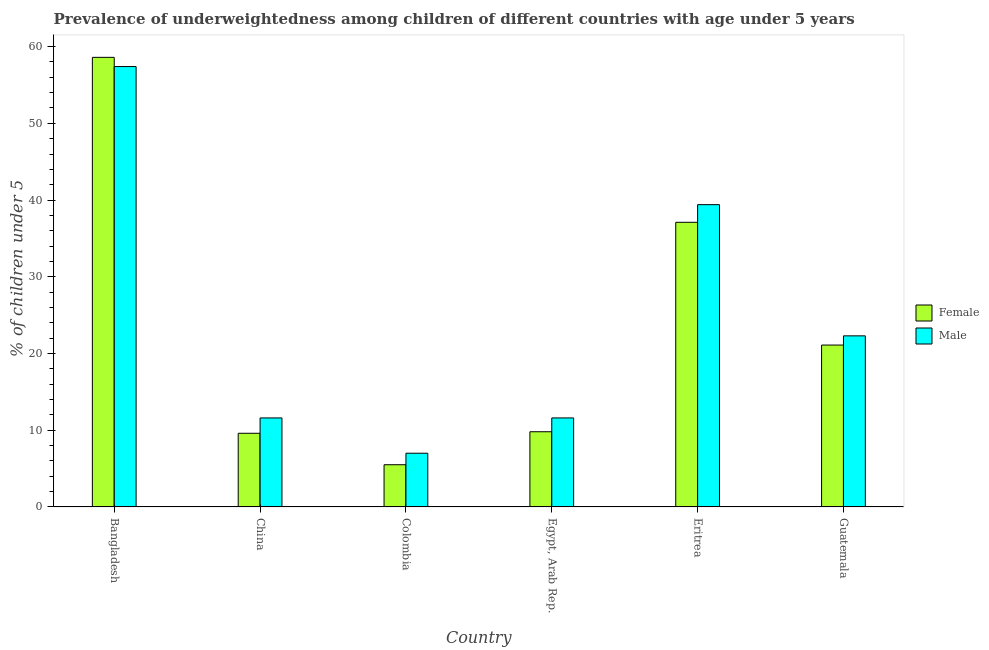How many different coloured bars are there?
Ensure brevity in your answer.  2. How many groups of bars are there?
Make the answer very short. 6. Are the number of bars on each tick of the X-axis equal?
Your response must be concise. Yes. How many bars are there on the 3rd tick from the left?
Ensure brevity in your answer.  2. How many bars are there on the 5th tick from the right?
Provide a short and direct response. 2. What is the label of the 5th group of bars from the left?
Provide a short and direct response. Eritrea. Across all countries, what is the maximum percentage of underweighted male children?
Make the answer very short. 57.4. In which country was the percentage of underweighted male children maximum?
Offer a terse response. Bangladesh. What is the total percentage of underweighted male children in the graph?
Provide a succinct answer. 149.3. What is the difference between the percentage of underweighted female children in China and that in Eritrea?
Offer a terse response. -27.5. What is the difference between the percentage of underweighted female children in China and the percentage of underweighted male children in Guatemala?
Offer a very short reply. -12.7. What is the average percentage of underweighted male children per country?
Offer a terse response. 24.88. What is the difference between the percentage of underweighted female children and percentage of underweighted male children in Guatemala?
Your response must be concise. -1.2. What is the ratio of the percentage of underweighted female children in Egypt, Arab Rep. to that in Guatemala?
Keep it short and to the point. 0.46. Is the difference between the percentage of underweighted male children in China and Eritrea greater than the difference between the percentage of underweighted female children in China and Eritrea?
Keep it short and to the point. No. What is the difference between the highest and the lowest percentage of underweighted male children?
Provide a short and direct response. 50.4. Is the sum of the percentage of underweighted male children in Bangladesh and Egypt, Arab Rep. greater than the maximum percentage of underweighted female children across all countries?
Provide a succinct answer. Yes. What does the 2nd bar from the right in Eritrea represents?
Give a very brief answer. Female. Are the values on the major ticks of Y-axis written in scientific E-notation?
Offer a very short reply. No. What is the title of the graph?
Offer a very short reply. Prevalence of underweightedness among children of different countries with age under 5 years. What is the label or title of the X-axis?
Give a very brief answer. Country. What is the label or title of the Y-axis?
Ensure brevity in your answer.   % of children under 5. What is the  % of children under 5 of Female in Bangladesh?
Provide a succinct answer. 58.6. What is the  % of children under 5 of Male in Bangladesh?
Ensure brevity in your answer.  57.4. What is the  % of children under 5 in Female in China?
Your response must be concise. 9.6. What is the  % of children under 5 of Male in China?
Provide a succinct answer. 11.6. What is the  % of children under 5 of Female in Egypt, Arab Rep.?
Provide a short and direct response. 9.8. What is the  % of children under 5 in Male in Egypt, Arab Rep.?
Your response must be concise. 11.6. What is the  % of children under 5 in Female in Eritrea?
Your response must be concise. 37.1. What is the  % of children under 5 of Male in Eritrea?
Your answer should be very brief. 39.4. What is the  % of children under 5 of Female in Guatemala?
Provide a succinct answer. 21.1. What is the  % of children under 5 of Male in Guatemala?
Your answer should be very brief. 22.3. Across all countries, what is the maximum  % of children under 5 in Female?
Provide a short and direct response. 58.6. Across all countries, what is the maximum  % of children under 5 of Male?
Offer a very short reply. 57.4. Across all countries, what is the minimum  % of children under 5 in Female?
Your response must be concise. 5.5. Across all countries, what is the minimum  % of children under 5 of Male?
Keep it short and to the point. 7. What is the total  % of children under 5 in Female in the graph?
Keep it short and to the point. 141.7. What is the total  % of children under 5 of Male in the graph?
Ensure brevity in your answer.  149.3. What is the difference between the  % of children under 5 of Male in Bangladesh and that in China?
Offer a terse response. 45.8. What is the difference between the  % of children under 5 in Female in Bangladesh and that in Colombia?
Provide a short and direct response. 53.1. What is the difference between the  % of children under 5 of Male in Bangladesh and that in Colombia?
Make the answer very short. 50.4. What is the difference between the  % of children under 5 of Female in Bangladesh and that in Egypt, Arab Rep.?
Keep it short and to the point. 48.8. What is the difference between the  % of children under 5 of Male in Bangladesh and that in Egypt, Arab Rep.?
Make the answer very short. 45.8. What is the difference between the  % of children under 5 of Male in Bangladesh and that in Eritrea?
Provide a short and direct response. 18. What is the difference between the  % of children under 5 in Female in Bangladesh and that in Guatemala?
Ensure brevity in your answer.  37.5. What is the difference between the  % of children under 5 in Male in Bangladesh and that in Guatemala?
Keep it short and to the point. 35.1. What is the difference between the  % of children under 5 in Female in China and that in Colombia?
Provide a succinct answer. 4.1. What is the difference between the  % of children under 5 in Female in China and that in Egypt, Arab Rep.?
Offer a terse response. -0.2. What is the difference between the  % of children under 5 of Male in China and that in Egypt, Arab Rep.?
Give a very brief answer. 0. What is the difference between the  % of children under 5 of Female in China and that in Eritrea?
Ensure brevity in your answer.  -27.5. What is the difference between the  % of children under 5 of Male in China and that in Eritrea?
Ensure brevity in your answer.  -27.8. What is the difference between the  % of children under 5 in Male in China and that in Guatemala?
Ensure brevity in your answer.  -10.7. What is the difference between the  % of children under 5 of Female in Colombia and that in Egypt, Arab Rep.?
Offer a very short reply. -4.3. What is the difference between the  % of children under 5 of Female in Colombia and that in Eritrea?
Make the answer very short. -31.6. What is the difference between the  % of children under 5 in Male in Colombia and that in Eritrea?
Ensure brevity in your answer.  -32.4. What is the difference between the  % of children under 5 of Female in Colombia and that in Guatemala?
Keep it short and to the point. -15.6. What is the difference between the  % of children under 5 of Male in Colombia and that in Guatemala?
Provide a short and direct response. -15.3. What is the difference between the  % of children under 5 of Female in Egypt, Arab Rep. and that in Eritrea?
Ensure brevity in your answer.  -27.3. What is the difference between the  % of children under 5 of Male in Egypt, Arab Rep. and that in Eritrea?
Your answer should be compact. -27.8. What is the difference between the  % of children under 5 in Female in Eritrea and that in Guatemala?
Your response must be concise. 16. What is the difference between the  % of children under 5 of Male in Eritrea and that in Guatemala?
Your answer should be compact. 17.1. What is the difference between the  % of children under 5 in Female in Bangladesh and the  % of children under 5 in Male in China?
Your response must be concise. 47. What is the difference between the  % of children under 5 in Female in Bangladesh and the  % of children under 5 in Male in Colombia?
Provide a succinct answer. 51.6. What is the difference between the  % of children under 5 in Female in Bangladesh and the  % of children under 5 in Male in Guatemala?
Give a very brief answer. 36.3. What is the difference between the  % of children under 5 in Female in China and the  % of children under 5 in Male in Colombia?
Give a very brief answer. 2.6. What is the difference between the  % of children under 5 of Female in China and the  % of children under 5 of Male in Egypt, Arab Rep.?
Offer a very short reply. -2. What is the difference between the  % of children under 5 of Female in China and the  % of children under 5 of Male in Eritrea?
Your response must be concise. -29.8. What is the difference between the  % of children under 5 of Female in Colombia and the  % of children under 5 of Male in Eritrea?
Provide a short and direct response. -33.9. What is the difference between the  % of children under 5 of Female in Colombia and the  % of children under 5 of Male in Guatemala?
Your answer should be very brief. -16.8. What is the difference between the  % of children under 5 of Female in Egypt, Arab Rep. and the  % of children under 5 of Male in Eritrea?
Offer a very short reply. -29.6. What is the difference between the  % of children under 5 of Female in Egypt, Arab Rep. and the  % of children under 5 of Male in Guatemala?
Keep it short and to the point. -12.5. What is the difference between the  % of children under 5 of Female in Eritrea and the  % of children under 5 of Male in Guatemala?
Give a very brief answer. 14.8. What is the average  % of children under 5 of Female per country?
Your answer should be compact. 23.62. What is the average  % of children under 5 of Male per country?
Keep it short and to the point. 24.88. What is the difference between the  % of children under 5 of Female and  % of children under 5 of Male in Bangladesh?
Keep it short and to the point. 1.2. What is the difference between the  % of children under 5 of Female and  % of children under 5 of Male in Eritrea?
Provide a short and direct response. -2.3. What is the difference between the  % of children under 5 of Female and  % of children under 5 of Male in Guatemala?
Provide a succinct answer. -1.2. What is the ratio of the  % of children under 5 in Female in Bangladesh to that in China?
Your answer should be compact. 6.1. What is the ratio of the  % of children under 5 in Male in Bangladesh to that in China?
Make the answer very short. 4.95. What is the ratio of the  % of children under 5 in Female in Bangladesh to that in Colombia?
Your answer should be very brief. 10.65. What is the ratio of the  % of children under 5 in Male in Bangladesh to that in Colombia?
Keep it short and to the point. 8.2. What is the ratio of the  % of children under 5 in Female in Bangladesh to that in Egypt, Arab Rep.?
Offer a very short reply. 5.98. What is the ratio of the  % of children under 5 of Male in Bangladesh to that in Egypt, Arab Rep.?
Provide a succinct answer. 4.95. What is the ratio of the  % of children under 5 in Female in Bangladesh to that in Eritrea?
Keep it short and to the point. 1.58. What is the ratio of the  % of children under 5 in Male in Bangladesh to that in Eritrea?
Your answer should be compact. 1.46. What is the ratio of the  % of children under 5 of Female in Bangladesh to that in Guatemala?
Offer a very short reply. 2.78. What is the ratio of the  % of children under 5 of Male in Bangladesh to that in Guatemala?
Make the answer very short. 2.57. What is the ratio of the  % of children under 5 of Female in China to that in Colombia?
Offer a very short reply. 1.75. What is the ratio of the  % of children under 5 of Male in China to that in Colombia?
Give a very brief answer. 1.66. What is the ratio of the  % of children under 5 of Female in China to that in Egypt, Arab Rep.?
Make the answer very short. 0.98. What is the ratio of the  % of children under 5 in Female in China to that in Eritrea?
Give a very brief answer. 0.26. What is the ratio of the  % of children under 5 in Male in China to that in Eritrea?
Make the answer very short. 0.29. What is the ratio of the  % of children under 5 of Female in China to that in Guatemala?
Keep it short and to the point. 0.46. What is the ratio of the  % of children under 5 in Male in China to that in Guatemala?
Give a very brief answer. 0.52. What is the ratio of the  % of children under 5 of Female in Colombia to that in Egypt, Arab Rep.?
Make the answer very short. 0.56. What is the ratio of the  % of children under 5 in Male in Colombia to that in Egypt, Arab Rep.?
Make the answer very short. 0.6. What is the ratio of the  % of children under 5 of Female in Colombia to that in Eritrea?
Give a very brief answer. 0.15. What is the ratio of the  % of children under 5 of Male in Colombia to that in Eritrea?
Make the answer very short. 0.18. What is the ratio of the  % of children under 5 in Female in Colombia to that in Guatemala?
Your response must be concise. 0.26. What is the ratio of the  % of children under 5 in Male in Colombia to that in Guatemala?
Give a very brief answer. 0.31. What is the ratio of the  % of children under 5 of Female in Egypt, Arab Rep. to that in Eritrea?
Make the answer very short. 0.26. What is the ratio of the  % of children under 5 of Male in Egypt, Arab Rep. to that in Eritrea?
Provide a succinct answer. 0.29. What is the ratio of the  % of children under 5 of Female in Egypt, Arab Rep. to that in Guatemala?
Ensure brevity in your answer.  0.46. What is the ratio of the  % of children under 5 in Male in Egypt, Arab Rep. to that in Guatemala?
Offer a terse response. 0.52. What is the ratio of the  % of children under 5 in Female in Eritrea to that in Guatemala?
Make the answer very short. 1.76. What is the ratio of the  % of children under 5 in Male in Eritrea to that in Guatemala?
Your answer should be compact. 1.77. What is the difference between the highest and the lowest  % of children under 5 in Female?
Keep it short and to the point. 53.1. What is the difference between the highest and the lowest  % of children under 5 in Male?
Ensure brevity in your answer.  50.4. 